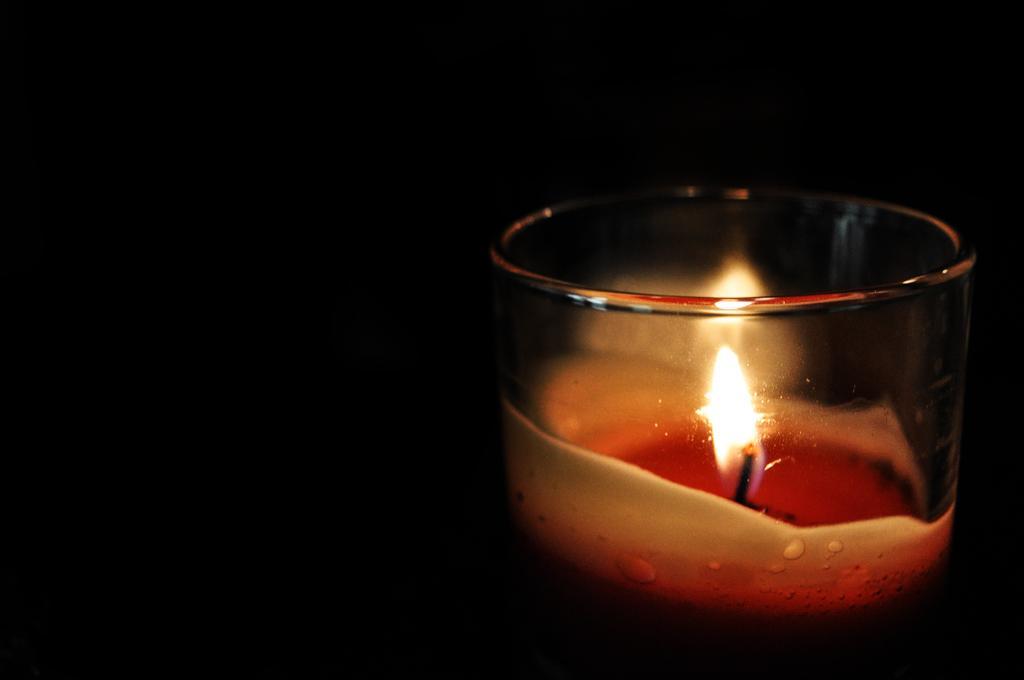Can you describe this image briefly? In this image I can see a glass in which I can see a candle and I can see the dark background. 